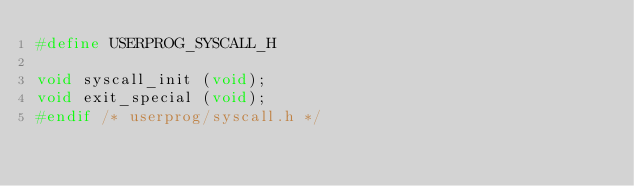Convert code to text. <code><loc_0><loc_0><loc_500><loc_500><_C_>#define USERPROG_SYSCALL_H

void syscall_init (void);
void exit_special (void);
#endif /* userprog/syscall.h */
</code> 